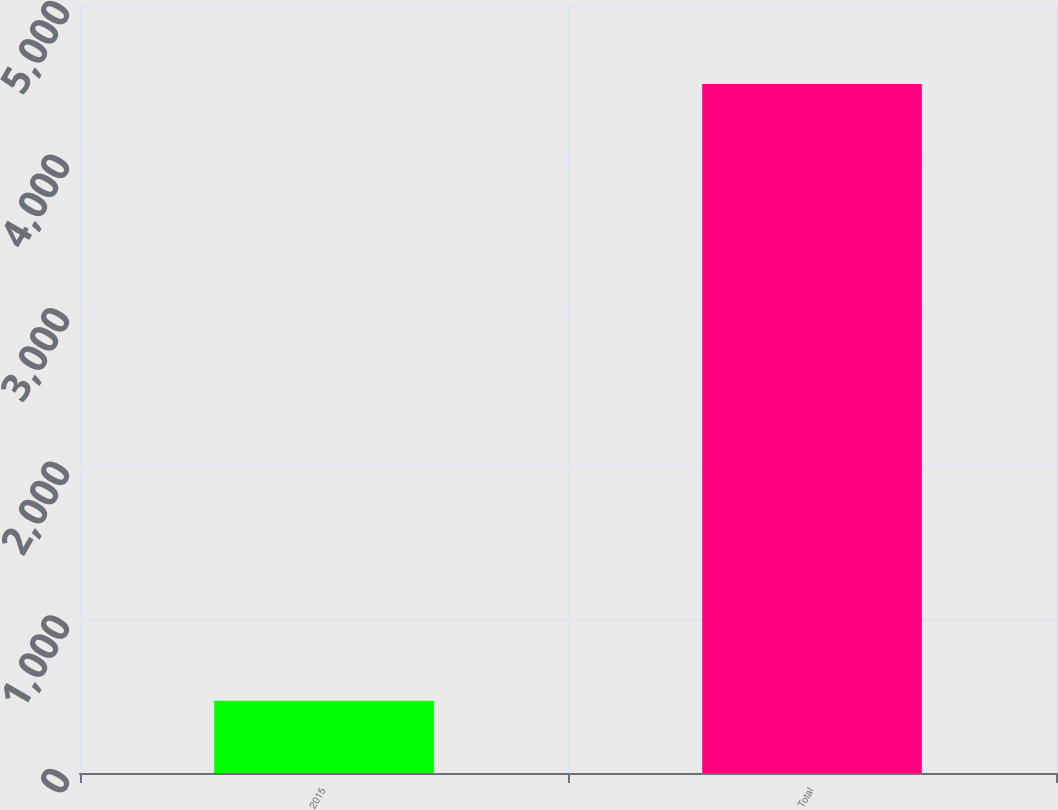<chart> <loc_0><loc_0><loc_500><loc_500><bar_chart><fcel>2015<fcel>Total<nl><fcel>471<fcel>4486<nl></chart> 